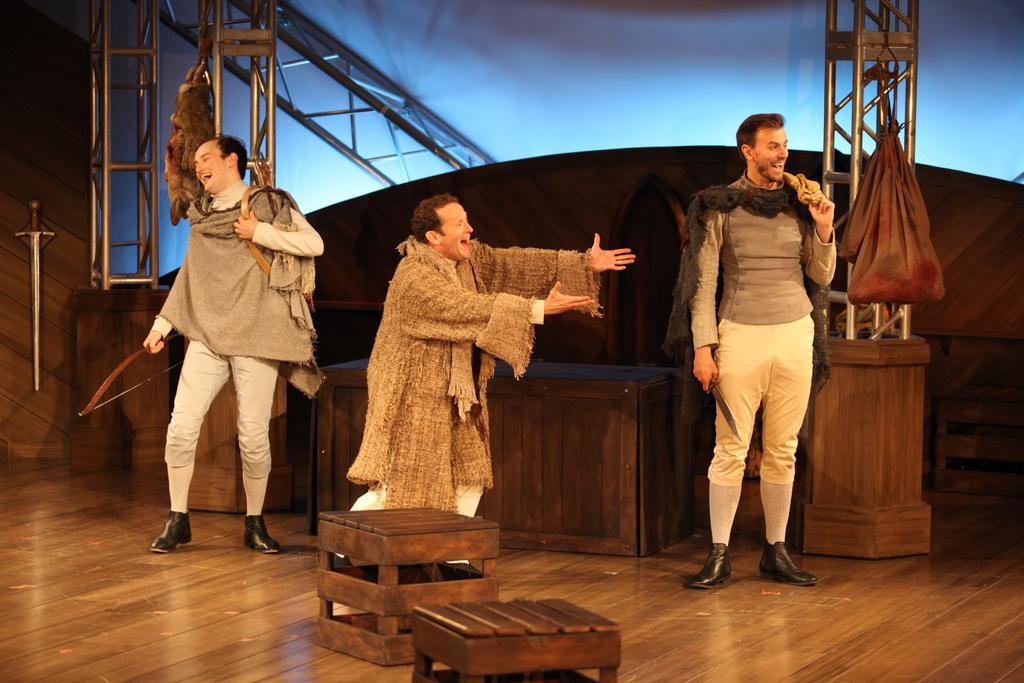Can you describe this image briefly? In the image in the center, we can see their persons are standing and they are smiling. In the background there is a wall, tables, pole type structures etc. 